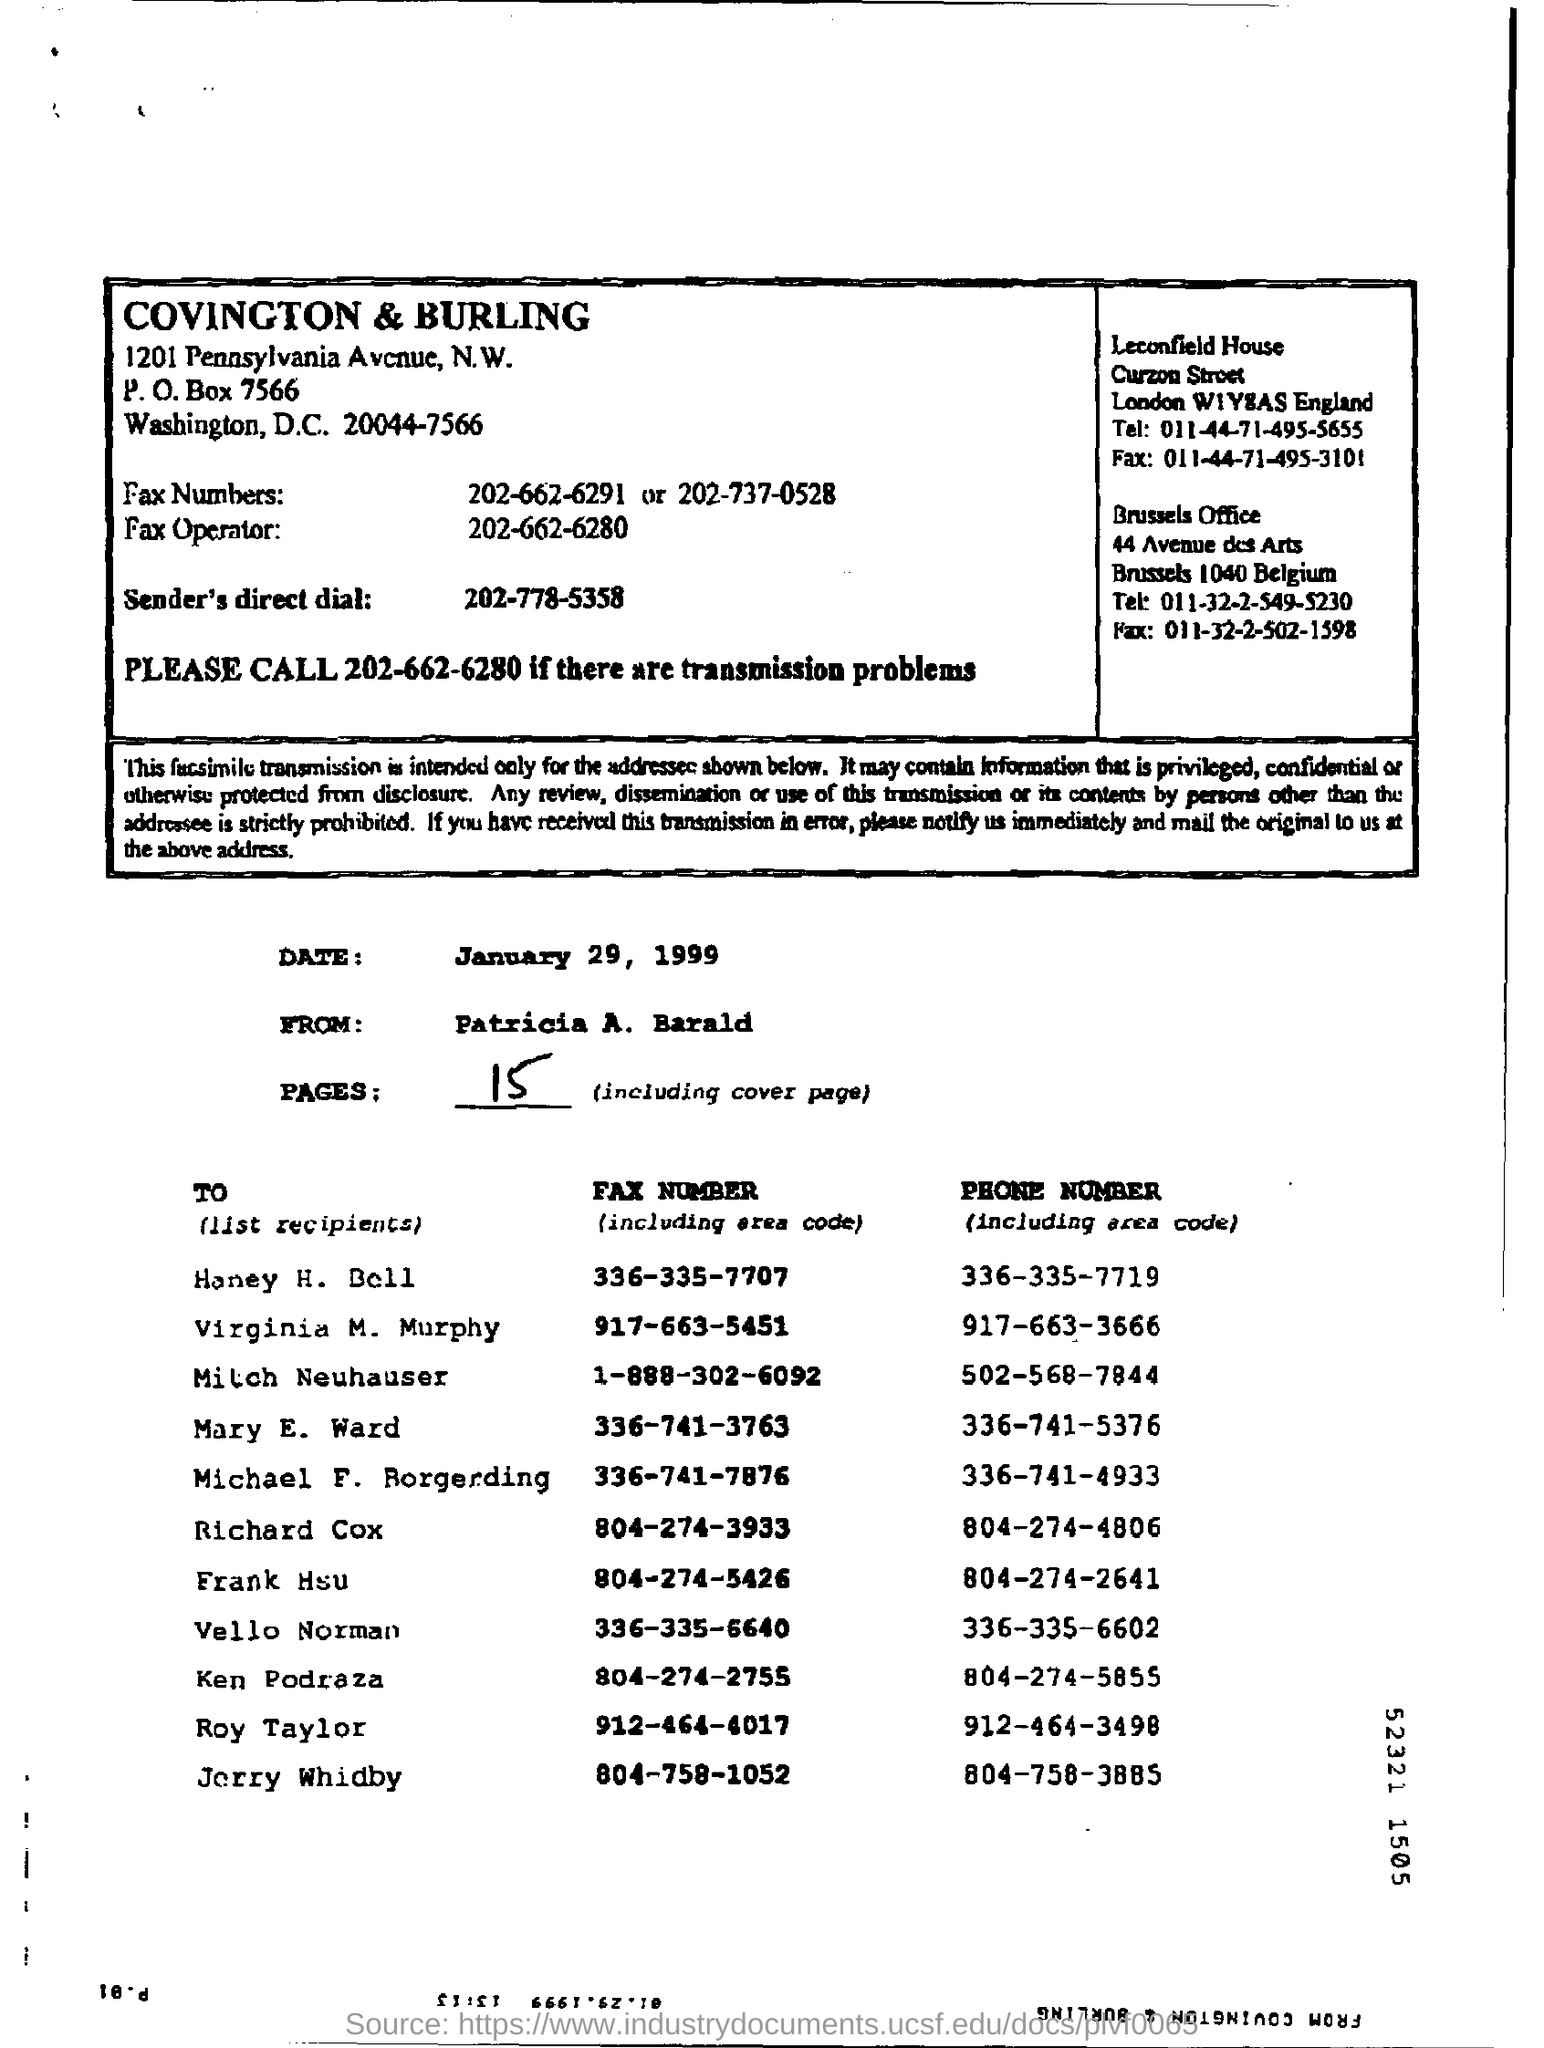What is phone number of of Roy Taylor?
Give a very brief answer. 912-464-3498. Phone number of Jorry Whidby?
Your response must be concise. 804-758-3885. What is Fax number of Honey H Bell?
Offer a very short reply. 336-335-7707. Number of pages including Cover?
Your answer should be compact. 15. What is the date mentioned in the document?
Keep it short and to the point. January 29, 1999. What is sender's direct dial?
Provide a succinct answer. 202-778-5358. 